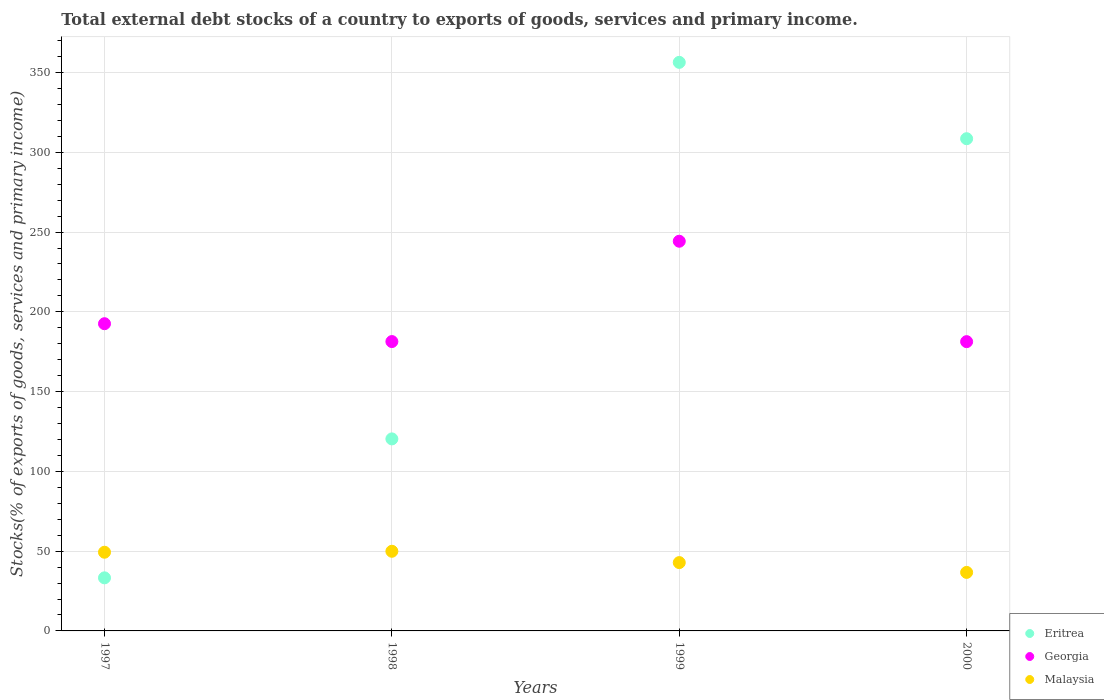Is the number of dotlines equal to the number of legend labels?
Provide a short and direct response. Yes. What is the total debt stocks in Georgia in 2000?
Ensure brevity in your answer.  181.32. Across all years, what is the maximum total debt stocks in Malaysia?
Your response must be concise. 49.93. Across all years, what is the minimum total debt stocks in Eritrea?
Offer a terse response. 33.27. In which year was the total debt stocks in Georgia maximum?
Give a very brief answer. 1999. In which year was the total debt stocks in Eritrea minimum?
Provide a succinct answer. 1997. What is the total total debt stocks in Eritrea in the graph?
Keep it short and to the point. 818.56. What is the difference between the total debt stocks in Eritrea in 1997 and that in 1999?
Offer a very short reply. -323.12. What is the difference between the total debt stocks in Eritrea in 1997 and the total debt stocks in Malaysia in 1999?
Provide a succinct answer. -9.55. What is the average total debt stocks in Eritrea per year?
Offer a terse response. 204.64. In the year 1999, what is the difference between the total debt stocks in Georgia and total debt stocks in Malaysia?
Provide a succinct answer. 201.44. In how many years, is the total debt stocks in Georgia greater than 90 %?
Keep it short and to the point. 4. What is the ratio of the total debt stocks in Georgia in 1999 to that in 2000?
Give a very brief answer. 1.35. What is the difference between the highest and the second highest total debt stocks in Georgia?
Offer a very short reply. 51.7. What is the difference between the highest and the lowest total debt stocks in Malaysia?
Keep it short and to the point. 13.25. In how many years, is the total debt stocks in Malaysia greater than the average total debt stocks in Malaysia taken over all years?
Provide a succinct answer. 2. Is it the case that in every year, the sum of the total debt stocks in Eritrea and total debt stocks in Malaysia  is greater than the total debt stocks in Georgia?
Keep it short and to the point. No. Is the total debt stocks in Malaysia strictly greater than the total debt stocks in Georgia over the years?
Your answer should be compact. No. How many dotlines are there?
Offer a very short reply. 3. Are the values on the major ticks of Y-axis written in scientific E-notation?
Your answer should be very brief. No. Does the graph contain any zero values?
Offer a very short reply. No. Does the graph contain grids?
Offer a terse response. Yes. How many legend labels are there?
Your response must be concise. 3. How are the legend labels stacked?
Your response must be concise. Vertical. What is the title of the graph?
Your response must be concise. Total external debt stocks of a country to exports of goods, services and primary income. What is the label or title of the X-axis?
Your answer should be compact. Years. What is the label or title of the Y-axis?
Ensure brevity in your answer.  Stocks(% of exports of goods, services and primary income). What is the Stocks(% of exports of goods, services and primary income) in Eritrea in 1997?
Offer a terse response. 33.27. What is the Stocks(% of exports of goods, services and primary income) in Georgia in 1997?
Offer a terse response. 192.57. What is the Stocks(% of exports of goods, services and primary income) in Malaysia in 1997?
Give a very brief answer. 49.32. What is the Stocks(% of exports of goods, services and primary income) of Eritrea in 1998?
Keep it short and to the point. 120.36. What is the Stocks(% of exports of goods, services and primary income) in Georgia in 1998?
Make the answer very short. 181.38. What is the Stocks(% of exports of goods, services and primary income) of Malaysia in 1998?
Provide a short and direct response. 49.93. What is the Stocks(% of exports of goods, services and primary income) of Eritrea in 1999?
Offer a terse response. 356.4. What is the Stocks(% of exports of goods, services and primary income) in Georgia in 1999?
Give a very brief answer. 244.27. What is the Stocks(% of exports of goods, services and primary income) of Malaysia in 1999?
Give a very brief answer. 42.82. What is the Stocks(% of exports of goods, services and primary income) in Eritrea in 2000?
Give a very brief answer. 308.53. What is the Stocks(% of exports of goods, services and primary income) of Georgia in 2000?
Keep it short and to the point. 181.32. What is the Stocks(% of exports of goods, services and primary income) of Malaysia in 2000?
Provide a short and direct response. 36.68. Across all years, what is the maximum Stocks(% of exports of goods, services and primary income) in Eritrea?
Offer a terse response. 356.4. Across all years, what is the maximum Stocks(% of exports of goods, services and primary income) of Georgia?
Provide a short and direct response. 244.27. Across all years, what is the maximum Stocks(% of exports of goods, services and primary income) of Malaysia?
Provide a short and direct response. 49.93. Across all years, what is the minimum Stocks(% of exports of goods, services and primary income) in Eritrea?
Keep it short and to the point. 33.27. Across all years, what is the minimum Stocks(% of exports of goods, services and primary income) in Georgia?
Offer a terse response. 181.32. Across all years, what is the minimum Stocks(% of exports of goods, services and primary income) of Malaysia?
Make the answer very short. 36.68. What is the total Stocks(% of exports of goods, services and primary income) in Eritrea in the graph?
Your response must be concise. 818.56. What is the total Stocks(% of exports of goods, services and primary income) in Georgia in the graph?
Keep it short and to the point. 799.53. What is the total Stocks(% of exports of goods, services and primary income) of Malaysia in the graph?
Your answer should be compact. 178.76. What is the difference between the Stocks(% of exports of goods, services and primary income) of Eritrea in 1997 and that in 1998?
Offer a very short reply. -87.09. What is the difference between the Stocks(% of exports of goods, services and primary income) in Georgia in 1997 and that in 1998?
Your response must be concise. 11.19. What is the difference between the Stocks(% of exports of goods, services and primary income) of Malaysia in 1997 and that in 1998?
Keep it short and to the point. -0.6. What is the difference between the Stocks(% of exports of goods, services and primary income) of Eritrea in 1997 and that in 1999?
Provide a succinct answer. -323.12. What is the difference between the Stocks(% of exports of goods, services and primary income) in Georgia in 1997 and that in 1999?
Offer a very short reply. -51.7. What is the difference between the Stocks(% of exports of goods, services and primary income) in Malaysia in 1997 and that in 1999?
Keep it short and to the point. 6.5. What is the difference between the Stocks(% of exports of goods, services and primary income) of Eritrea in 1997 and that in 2000?
Give a very brief answer. -275.26. What is the difference between the Stocks(% of exports of goods, services and primary income) of Georgia in 1997 and that in 2000?
Ensure brevity in your answer.  11.24. What is the difference between the Stocks(% of exports of goods, services and primary income) in Malaysia in 1997 and that in 2000?
Your response must be concise. 12.64. What is the difference between the Stocks(% of exports of goods, services and primary income) of Eritrea in 1998 and that in 1999?
Offer a very short reply. -236.03. What is the difference between the Stocks(% of exports of goods, services and primary income) of Georgia in 1998 and that in 1999?
Offer a very short reply. -62.89. What is the difference between the Stocks(% of exports of goods, services and primary income) in Malaysia in 1998 and that in 1999?
Offer a terse response. 7.1. What is the difference between the Stocks(% of exports of goods, services and primary income) of Eritrea in 1998 and that in 2000?
Keep it short and to the point. -188.17. What is the difference between the Stocks(% of exports of goods, services and primary income) in Georgia in 1998 and that in 2000?
Offer a very short reply. 0.05. What is the difference between the Stocks(% of exports of goods, services and primary income) in Malaysia in 1998 and that in 2000?
Offer a terse response. 13.25. What is the difference between the Stocks(% of exports of goods, services and primary income) of Eritrea in 1999 and that in 2000?
Your answer should be compact. 47.86. What is the difference between the Stocks(% of exports of goods, services and primary income) of Georgia in 1999 and that in 2000?
Offer a very short reply. 62.94. What is the difference between the Stocks(% of exports of goods, services and primary income) in Malaysia in 1999 and that in 2000?
Your answer should be compact. 6.14. What is the difference between the Stocks(% of exports of goods, services and primary income) of Eritrea in 1997 and the Stocks(% of exports of goods, services and primary income) of Georgia in 1998?
Make the answer very short. -148.11. What is the difference between the Stocks(% of exports of goods, services and primary income) in Eritrea in 1997 and the Stocks(% of exports of goods, services and primary income) in Malaysia in 1998?
Offer a very short reply. -16.66. What is the difference between the Stocks(% of exports of goods, services and primary income) of Georgia in 1997 and the Stocks(% of exports of goods, services and primary income) of Malaysia in 1998?
Give a very brief answer. 142.64. What is the difference between the Stocks(% of exports of goods, services and primary income) of Eritrea in 1997 and the Stocks(% of exports of goods, services and primary income) of Georgia in 1999?
Keep it short and to the point. -210.99. What is the difference between the Stocks(% of exports of goods, services and primary income) in Eritrea in 1997 and the Stocks(% of exports of goods, services and primary income) in Malaysia in 1999?
Your response must be concise. -9.55. What is the difference between the Stocks(% of exports of goods, services and primary income) of Georgia in 1997 and the Stocks(% of exports of goods, services and primary income) of Malaysia in 1999?
Offer a very short reply. 149.74. What is the difference between the Stocks(% of exports of goods, services and primary income) of Eritrea in 1997 and the Stocks(% of exports of goods, services and primary income) of Georgia in 2000?
Offer a terse response. -148.05. What is the difference between the Stocks(% of exports of goods, services and primary income) of Eritrea in 1997 and the Stocks(% of exports of goods, services and primary income) of Malaysia in 2000?
Make the answer very short. -3.41. What is the difference between the Stocks(% of exports of goods, services and primary income) of Georgia in 1997 and the Stocks(% of exports of goods, services and primary income) of Malaysia in 2000?
Your answer should be very brief. 155.89. What is the difference between the Stocks(% of exports of goods, services and primary income) in Eritrea in 1998 and the Stocks(% of exports of goods, services and primary income) in Georgia in 1999?
Your response must be concise. -123.9. What is the difference between the Stocks(% of exports of goods, services and primary income) of Eritrea in 1998 and the Stocks(% of exports of goods, services and primary income) of Malaysia in 1999?
Keep it short and to the point. 77.54. What is the difference between the Stocks(% of exports of goods, services and primary income) of Georgia in 1998 and the Stocks(% of exports of goods, services and primary income) of Malaysia in 1999?
Provide a succinct answer. 138.55. What is the difference between the Stocks(% of exports of goods, services and primary income) of Eritrea in 1998 and the Stocks(% of exports of goods, services and primary income) of Georgia in 2000?
Your response must be concise. -60.96. What is the difference between the Stocks(% of exports of goods, services and primary income) of Eritrea in 1998 and the Stocks(% of exports of goods, services and primary income) of Malaysia in 2000?
Provide a short and direct response. 83.68. What is the difference between the Stocks(% of exports of goods, services and primary income) of Georgia in 1998 and the Stocks(% of exports of goods, services and primary income) of Malaysia in 2000?
Make the answer very short. 144.7. What is the difference between the Stocks(% of exports of goods, services and primary income) in Eritrea in 1999 and the Stocks(% of exports of goods, services and primary income) in Georgia in 2000?
Give a very brief answer. 175.07. What is the difference between the Stocks(% of exports of goods, services and primary income) in Eritrea in 1999 and the Stocks(% of exports of goods, services and primary income) in Malaysia in 2000?
Your answer should be very brief. 319.72. What is the difference between the Stocks(% of exports of goods, services and primary income) of Georgia in 1999 and the Stocks(% of exports of goods, services and primary income) of Malaysia in 2000?
Your response must be concise. 207.58. What is the average Stocks(% of exports of goods, services and primary income) of Eritrea per year?
Make the answer very short. 204.64. What is the average Stocks(% of exports of goods, services and primary income) of Georgia per year?
Provide a short and direct response. 199.88. What is the average Stocks(% of exports of goods, services and primary income) of Malaysia per year?
Provide a short and direct response. 44.69. In the year 1997, what is the difference between the Stocks(% of exports of goods, services and primary income) in Eritrea and Stocks(% of exports of goods, services and primary income) in Georgia?
Keep it short and to the point. -159.3. In the year 1997, what is the difference between the Stocks(% of exports of goods, services and primary income) in Eritrea and Stocks(% of exports of goods, services and primary income) in Malaysia?
Your answer should be very brief. -16.05. In the year 1997, what is the difference between the Stocks(% of exports of goods, services and primary income) in Georgia and Stocks(% of exports of goods, services and primary income) in Malaysia?
Your response must be concise. 143.24. In the year 1998, what is the difference between the Stocks(% of exports of goods, services and primary income) in Eritrea and Stocks(% of exports of goods, services and primary income) in Georgia?
Provide a succinct answer. -61.02. In the year 1998, what is the difference between the Stocks(% of exports of goods, services and primary income) in Eritrea and Stocks(% of exports of goods, services and primary income) in Malaysia?
Give a very brief answer. 70.43. In the year 1998, what is the difference between the Stocks(% of exports of goods, services and primary income) of Georgia and Stocks(% of exports of goods, services and primary income) of Malaysia?
Make the answer very short. 131.45. In the year 1999, what is the difference between the Stocks(% of exports of goods, services and primary income) in Eritrea and Stocks(% of exports of goods, services and primary income) in Georgia?
Provide a short and direct response. 112.13. In the year 1999, what is the difference between the Stocks(% of exports of goods, services and primary income) of Eritrea and Stocks(% of exports of goods, services and primary income) of Malaysia?
Give a very brief answer. 313.57. In the year 1999, what is the difference between the Stocks(% of exports of goods, services and primary income) of Georgia and Stocks(% of exports of goods, services and primary income) of Malaysia?
Provide a succinct answer. 201.44. In the year 2000, what is the difference between the Stocks(% of exports of goods, services and primary income) in Eritrea and Stocks(% of exports of goods, services and primary income) in Georgia?
Your answer should be very brief. 127.21. In the year 2000, what is the difference between the Stocks(% of exports of goods, services and primary income) of Eritrea and Stocks(% of exports of goods, services and primary income) of Malaysia?
Give a very brief answer. 271.85. In the year 2000, what is the difference between the Stocks(% of exports of goods, services and primary income) of Georgia and Stocks(% of exports of goods, services and primary income) of Malaysia?
Your response must be concise. 144.64. What is the ratio of the Stocks(% of exports of goods, services and primary income) of Eritrea in 1997 to that in 1998?
Your response must be concise. 0.28. What is the ratio of the Stocks(% of exports of goods, services and primary income) of Georgia in 1997 to that in 1998?
Provide a succinct answer. 1.06. What is the ratio of the Stocks(% of exports of goods, services and primary income) in Malaysia in 1997 to that in 1998?
Offer a terse response. 0.99. What is the ratio of the Stocks(% of exports of goods, services and primary income) in Eritrea in 1997 to that in 1999?
Make the answer very short. 0.09. What is the ratio of the Stocks(% of exports of goods, services and primary income) in Georgia in 1997 to that in 1999?
Make the answer very short. 0.79. What is the ratio of the Stocks(% of exports of goods, services and primary income) of Malaysia in 1997 to that in 1999?
Offer a terse response. 1.15. What is the ratio of the Stocks(% of exports of goods, services and primary income) in Eritrea in 1997 to that in 2000?
Provide a succinct answer. 0.11. What is the ratio of the Stocks(% of exports of goods, services and primary income) of Georgia in 1997 to that in 2000?
Your response must be concise. 1.06. What is the ratio of the Stocks(% of exports of goods, services and primary income) of Malaysia in 1997 to that in 2000?
Keep it short and to the point. 1.34. What is the ratio of the Stocks(% of exports of goods, services and primary income) in Eritrea in 1998 to that in 1999?
Keep it short and to the point. 0.34. What is the ratio of the Stocks(% of exports of goods, services and primary income) of Georgia in 1998 to that in 1999?
Ensure brevity in your answer.  0.74. What is the ratio of the Stocks(% of exports of goods, services and primary income) in Malaysia in 1998 to that in 1999?
Make the answer very short. 1.17. What is the ratio of the Stocks(% of exports of goods, services and primary income) in Eritrea in 1998 to that in 2000?
Ensure brevity in your answer.  0.39. What is the ratio of the Stocks(% of exports of goods, services and primary income) of Georgia in 1998 to that in 2000?
Give a very brief answer. 1. What is the ratio of the Stocks(% of exports of goods, services and primary income) in Malaysia in 1998 to that in 2000?
Your answer should be very brief. 1.36. What is the ratio of the Stocks(% of exports of goods, services and primary income) of Eritrea in 1999 to that in 2000?
Offer a very short reply. 1.16. What is the ratio of the Stocks(% of exports of goods, services and primary income) of Georgia in 1999 to that in 2000?
Give a very brief answer. 1.35. What is the ratio of the Stocks(% of exports of goods, services and primary income) in Malaysia in 1999 to that in 2000?
Provide a short and direct response. 1.17. What is the difference between the highest and the second highest Stocks(% of exports of goods, services and primary income) of Eritrea?
Provide a succinct answer. 47.86. What is the difference between the highest and the second highest Stocks(% of exports of goods, services and primary income) in Georgia?
Offer a very short reply. 51.7. What is the difference between the highest and the second highest Stocks(% of exports of goods, services and primary income) in Malaysia?
Provide a succinct answer. 0.6. What is the difference between the highest and the lowest Stocks(% of exports of goods, services and primary income) in Eritrea?
Your response must be concise. 323.12. What is the difference between the highest and the lowest Stocks(% of exports of goods, services and primary income) of Georgia?
Provide a short and direct response. 62.94. What is the difference between the highest and the lowest Stocks(% of exports of goods, services and primary income) in Malaysia?
Keep it short and to the point. 13.25. 